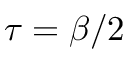<formula> <loc_0><loc_0><loc_500><loc_500>\tau = \beta / 2</formula> 